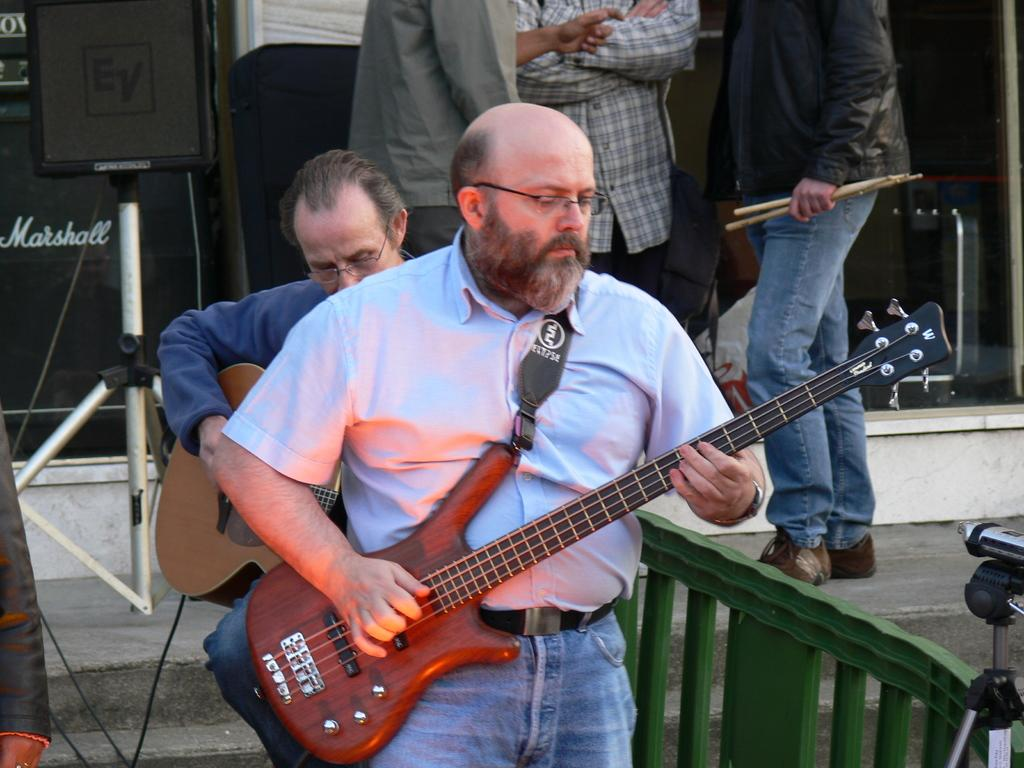What is the main activity being performed by the people in the image? The people in the image are playing guitars. How many guitar players are there in the image? There are two guitar players in the image. Are there any other people present in the image besides the guitar players? Yes, there are three people standing behind the two guitar players. What type of carriage can be seen in the background of the image? There is no carriage present in the image. Is there a bath visible in the image? No, there is no bath visible in the image. 